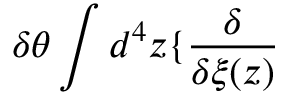<formula> <loc_0><loc_0><loc_500><loc_500>\delta \theta \int d ^ { 4 } z \{ \frac { \delta } { \delta \xi ( z ) }</formula> 